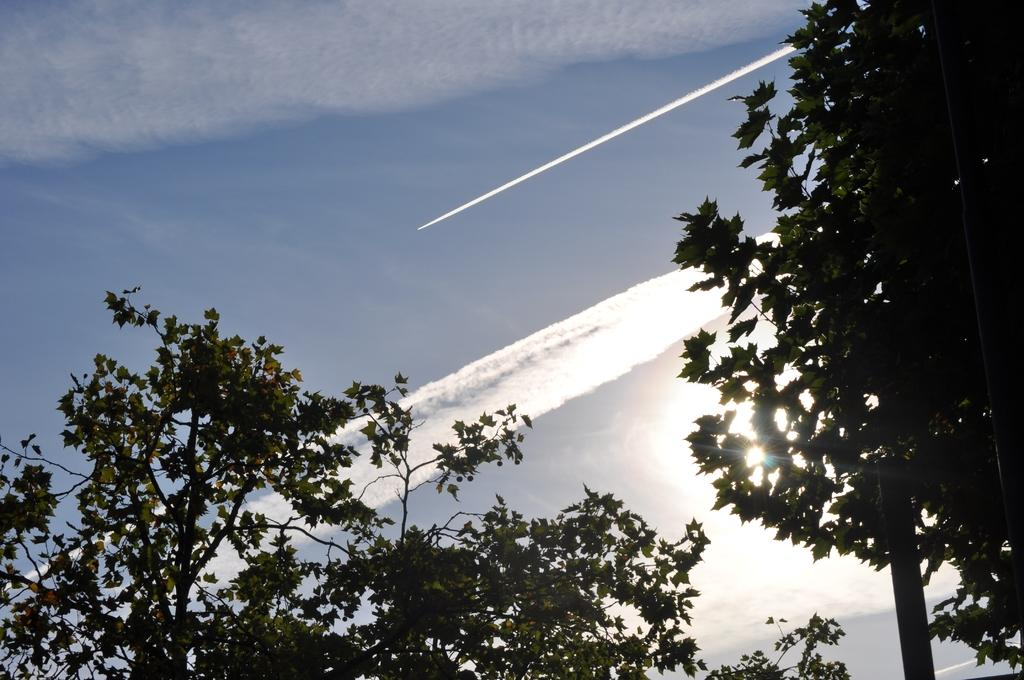What is located in the foreground of the image? There are trees in the foreground of the image. What can be seen in the sky in the image? There is a rocket's smoke visible in the sky, and another rocket is moving in the sky. What is the condition of the sky in the image? The sky is visible in the image, and clouds are present in the sky. How does the paper affect the movement of the rocket in the image? There is no paper present in the image, so it cannot affect the movement of the rocket. Can you compare the size of the trees in the foreground to the size of the rocket in the sky? The size comparison cannot be made accurately without a reference point or scale in the image. 